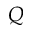<formula> <loc_0><loc_0><loc_500><loc_500>Q</formula> 